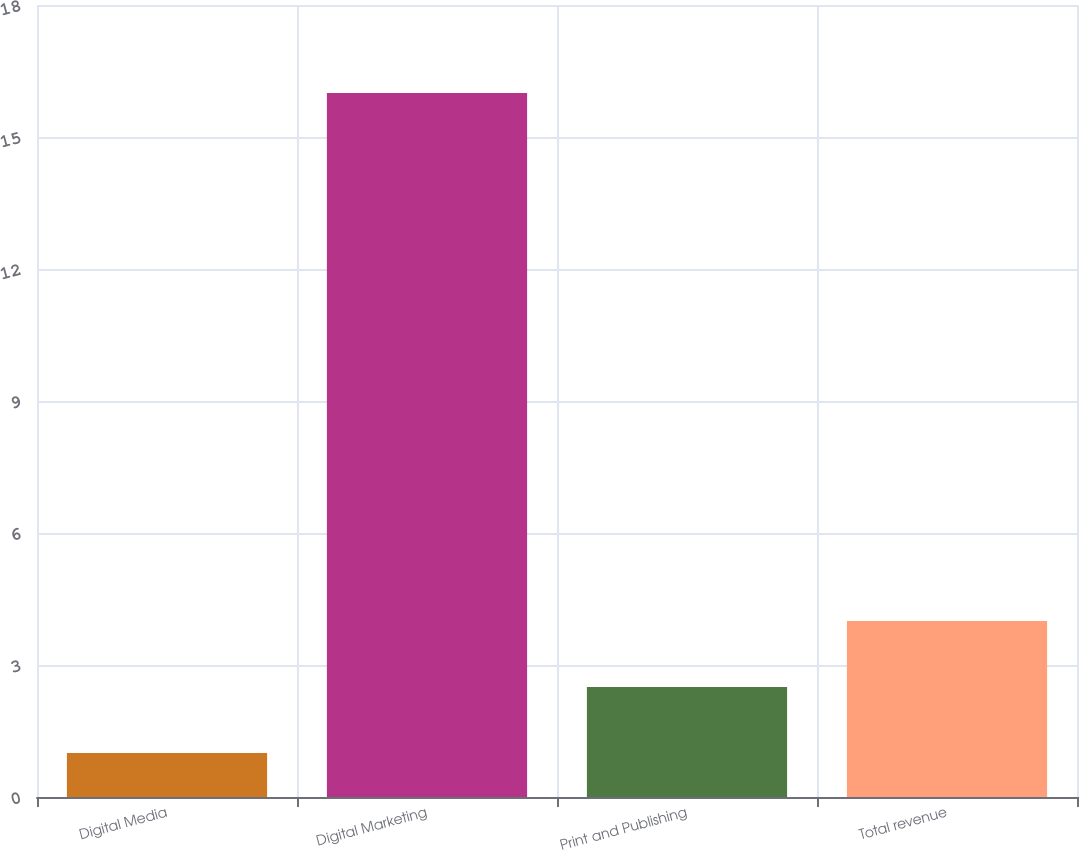Convert chart. <chart><loc_0><loc_0><loc_500><loc_500><bar_chart><fcel>Digital Media<fcel>Digital Marketing<fcel>Print and Publishing<fcel>Total revenue<nl><fcel>1<fcel>16<fcel>2.5<fcel>4<nl></chart> 